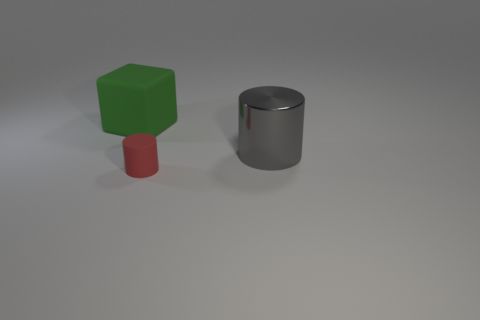How many other objects are there of the same material as the big green object?
Keep it short and to the point. 1. There is a green block that is the same size as the gray metallic thing; what is its material?
Give a very brief answer. Rubber. Are there fewer objects on the right side of the shiny object than big blue objects?
Offer a very short reply. No. There is a large object to the right of the object that is behind the thing right of the small red matte cylinder; what is its shape?
Your response must be concise. Cylinder. There is a object that is in front of the shiny cylinder; how big is it?
Give a very brief answer. Small. What is the shape of the gray object that is the same size as the green rubber thing?
Offer a very short reply. Cylinder. What number of objects are either small brown objects or objects that are to the right of the large rubber object?
Offer a very short reply. 2. There is a big object in front of the matte object to the left of the small red rubber cylinder; what number of rubber objects are left of it?
Make the answer very short. 2. There is a cylinder that is made of the same material as the green block; what color is it?
Ensure brevity in your answer.  Red. Is the size of the matte object that is in front of the green matte cube the same as the big metal thing?
Ensure brevity in your answer.  No. 